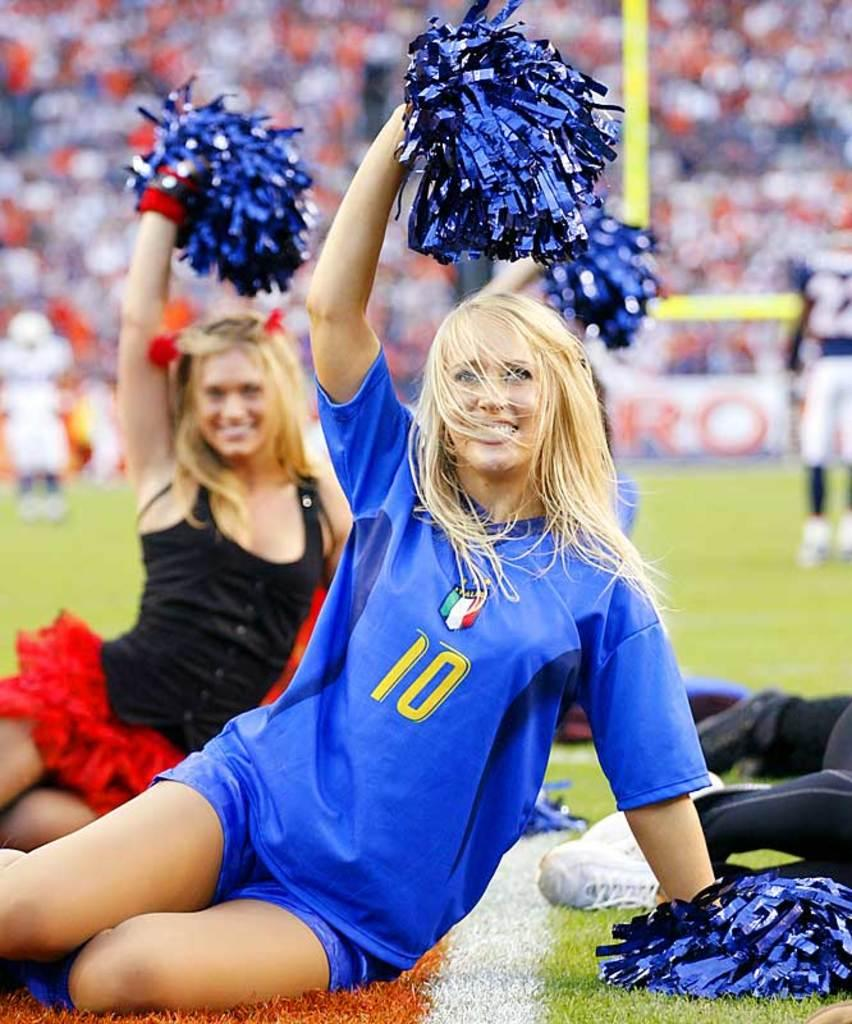<image>
Describe the image concisely. The cheerleader's blue short sleeve shirt has the number 10 on the front. 